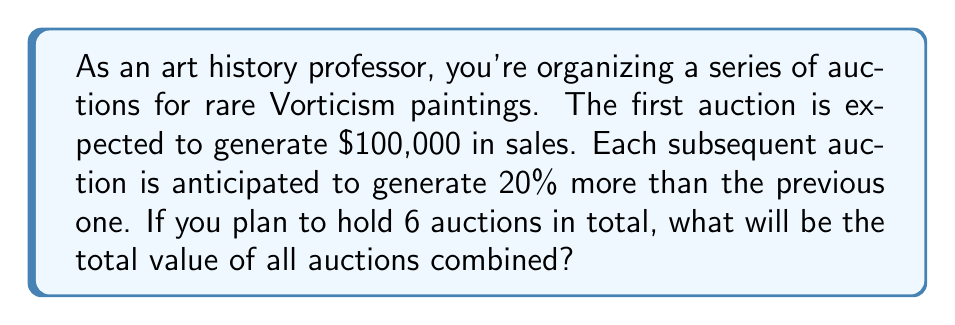Can you answer this question? Let's approach this step-by-step using the concept of geometric series:

1) We have a geometric series where:
   - First term, $a = 100,000$
   - Common ratio, $r = 1.20$ (20% increase = 1 + 0.20 = 1.20)
   - Number of terms, $n = 6$

2) The formula for the sum of a geometric series is:

   $$S_n = \frac{a(1-r^n)}{1-r}$$

   Where $S_n$ is the sum of $n$ terms, $a$ is the first term, and $r$ is the common ratio.

3) Substituting our values:

   $$S_6 = \frac{100,000(1-1.20^6)}{1-1.20}$$

4) Let's calculate $1.20^6$:
   
   $$1.20^6 = 2.98598$$

5) Now our equation looks like:

   $$S_6 = \frac{100,000(1-2.98598)}{1-1.20} = \frac{100,000(-1.98598)}{-0.20}$$

6) Simplifying:

   $$S_6 = 993,990$$

Therefore, the total value of all 6 auctions combined will be $993,990.
Answer: $993,990 